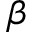<formula> <loc_0><loc_0><loc_500><loc_500>\beta</formula> 